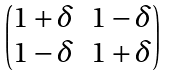Convert formula to latex. <formula><loc_0><loc_0><loc_500><loc_500>\begin{pmatrix} 1 + \delta & 1 - \delta \\ 1 - \delta & 1 + \delta \end{pmatrix}</formula> 